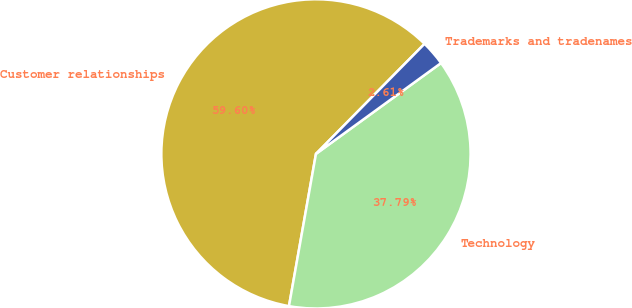Convert chart. <chart><loc_0><loc_0><loc_500><loc_500><pie_chart><fcel>Customer relationships<fcel>Technology<fcel>Trademarks and tradenames<nl><fcel>59.6%<fcel>37.79%<fcel>2.61%<nl></chart> 